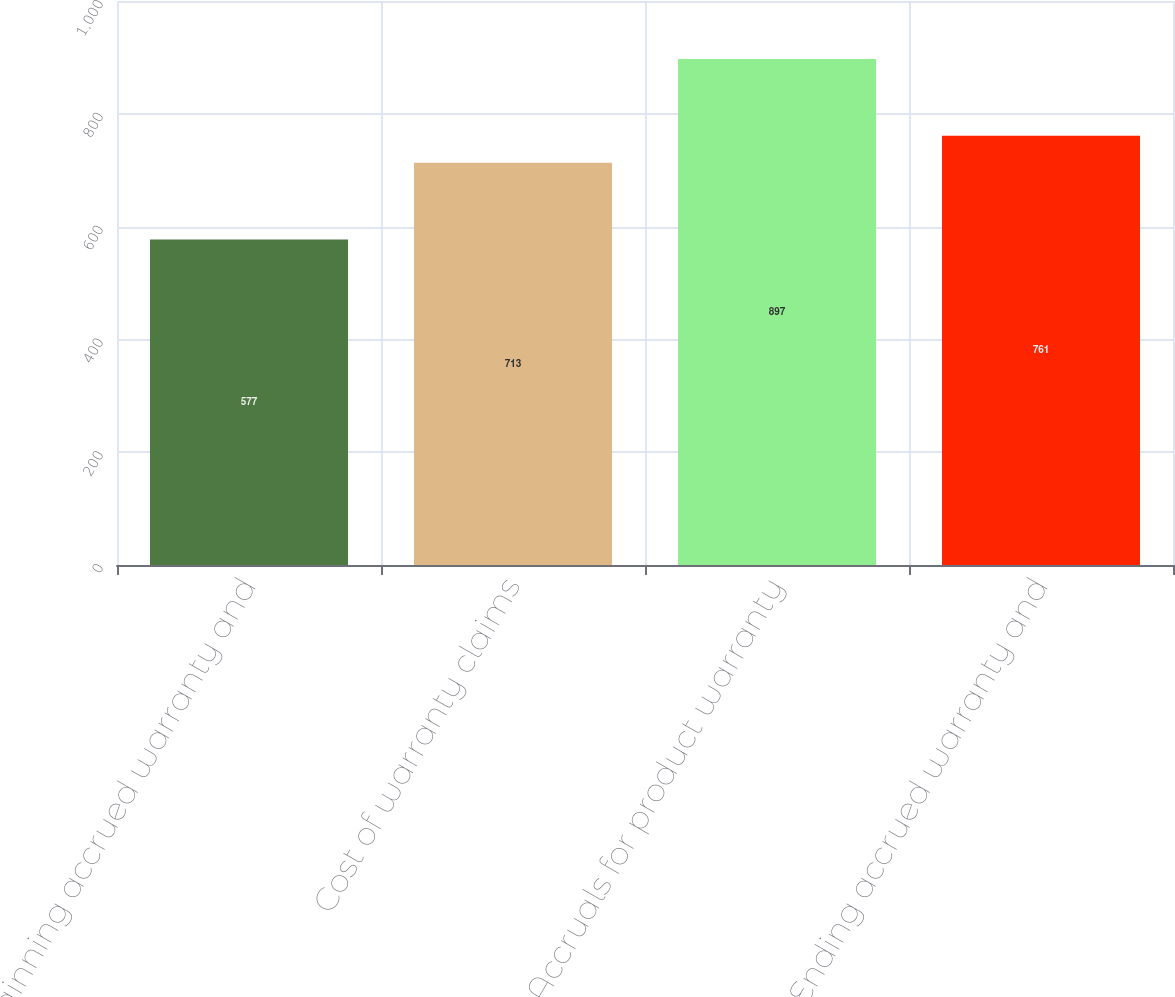Convert chart to OTSL. <chart><loc_0><loc_0><loc_500><loc_500><bar_chart><fcel>Beginning accrued warranty and<fcel>Cost of warranty claims<fcel>Accruals for product warranty<fcel>Ending accrued warranty and<nl><fcel>577<fcel>713<fcel>897<fcel>761<nl></chart> 